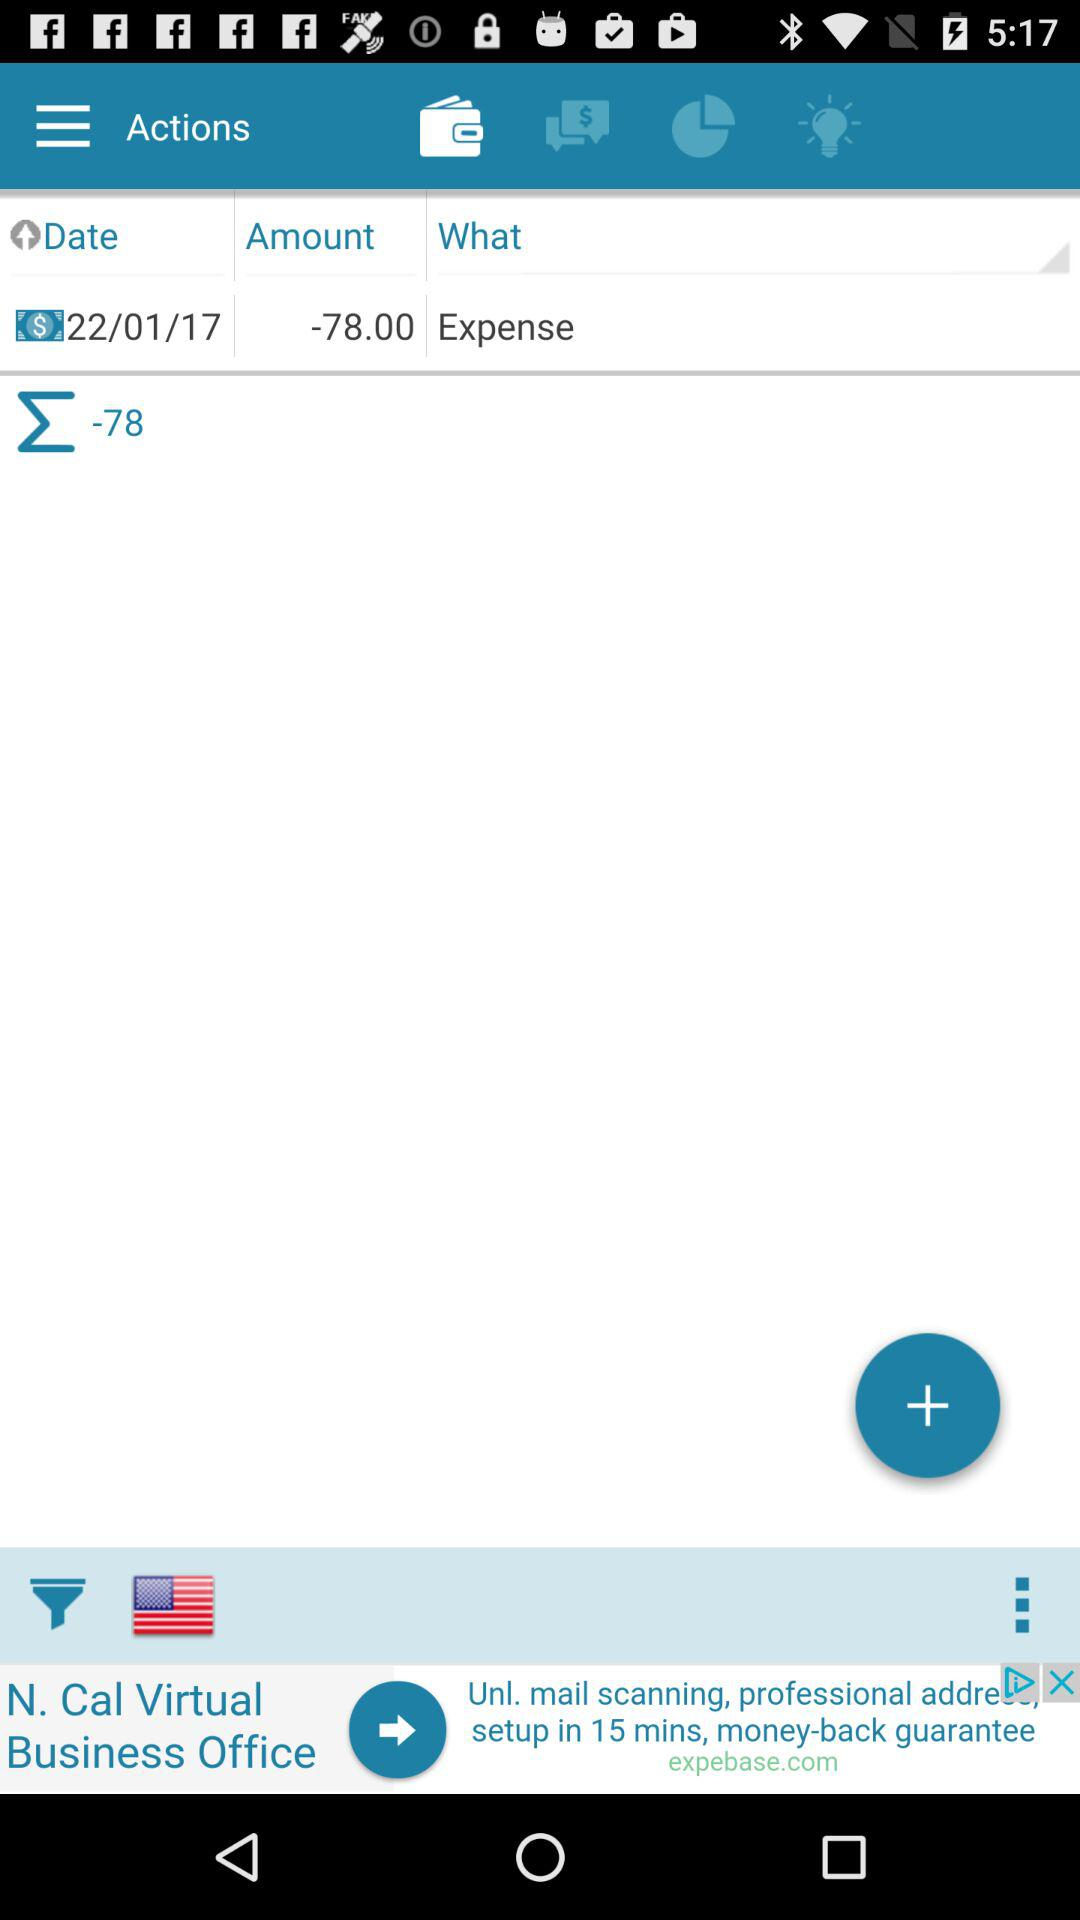How many expenses are there?
Answer the question using a single word or phrase. 1 